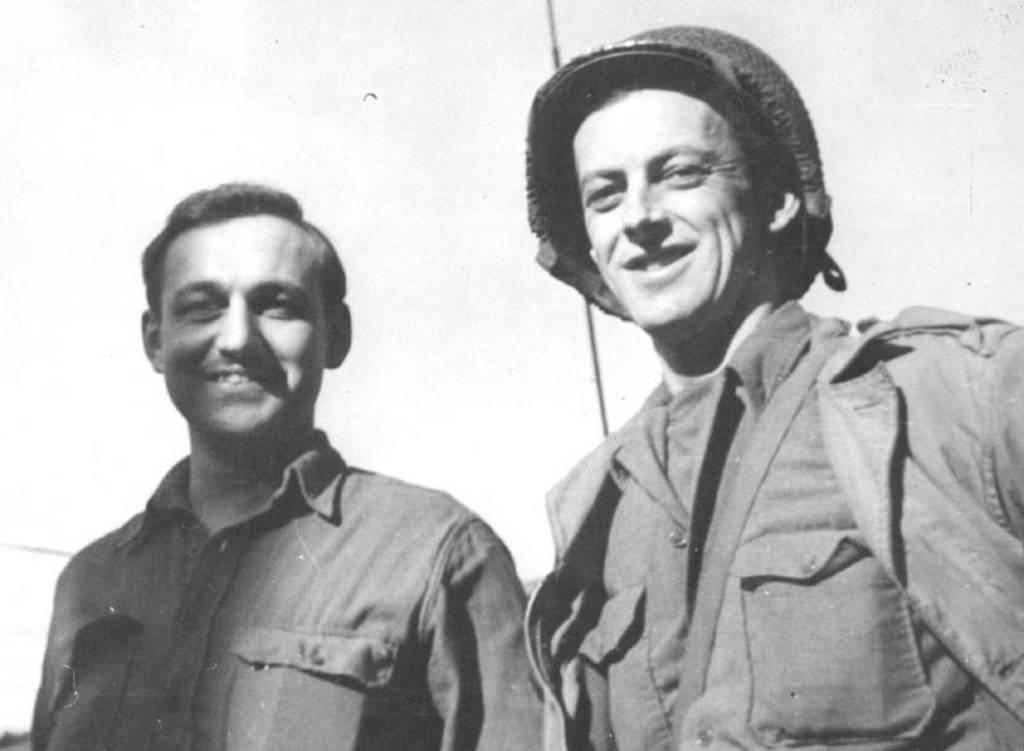Can you describe this image briefly? In this black and white picture there are two men standing. They are smiling. The man to the right is wearing a helmet. The background is white. 